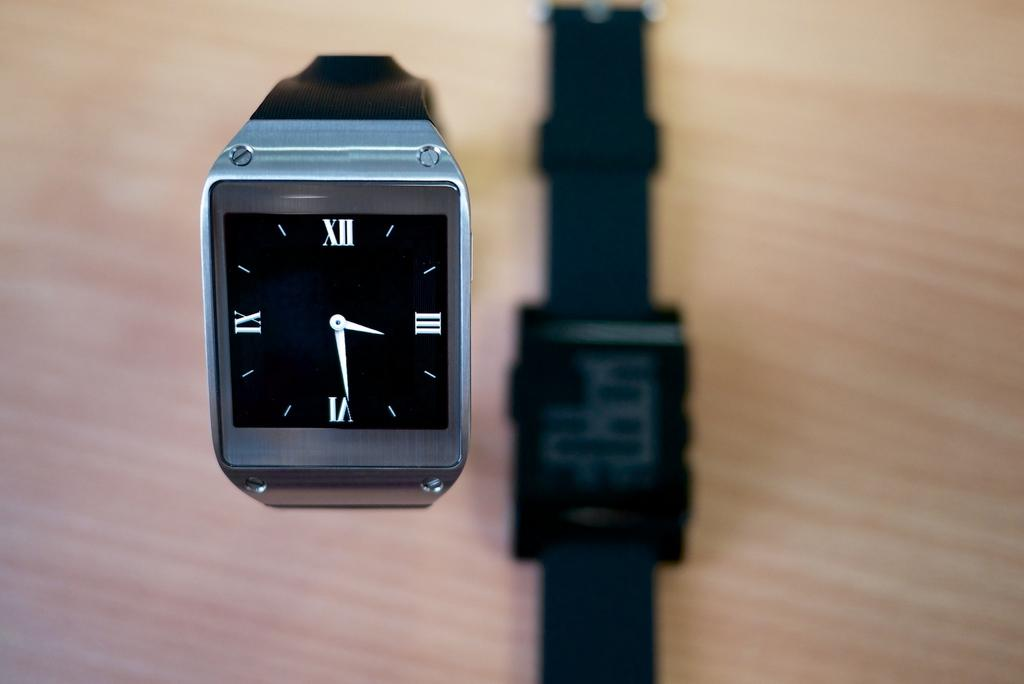Provide a one-sentence caption for the provided image. A black and silver watch reads three twenty nine. 